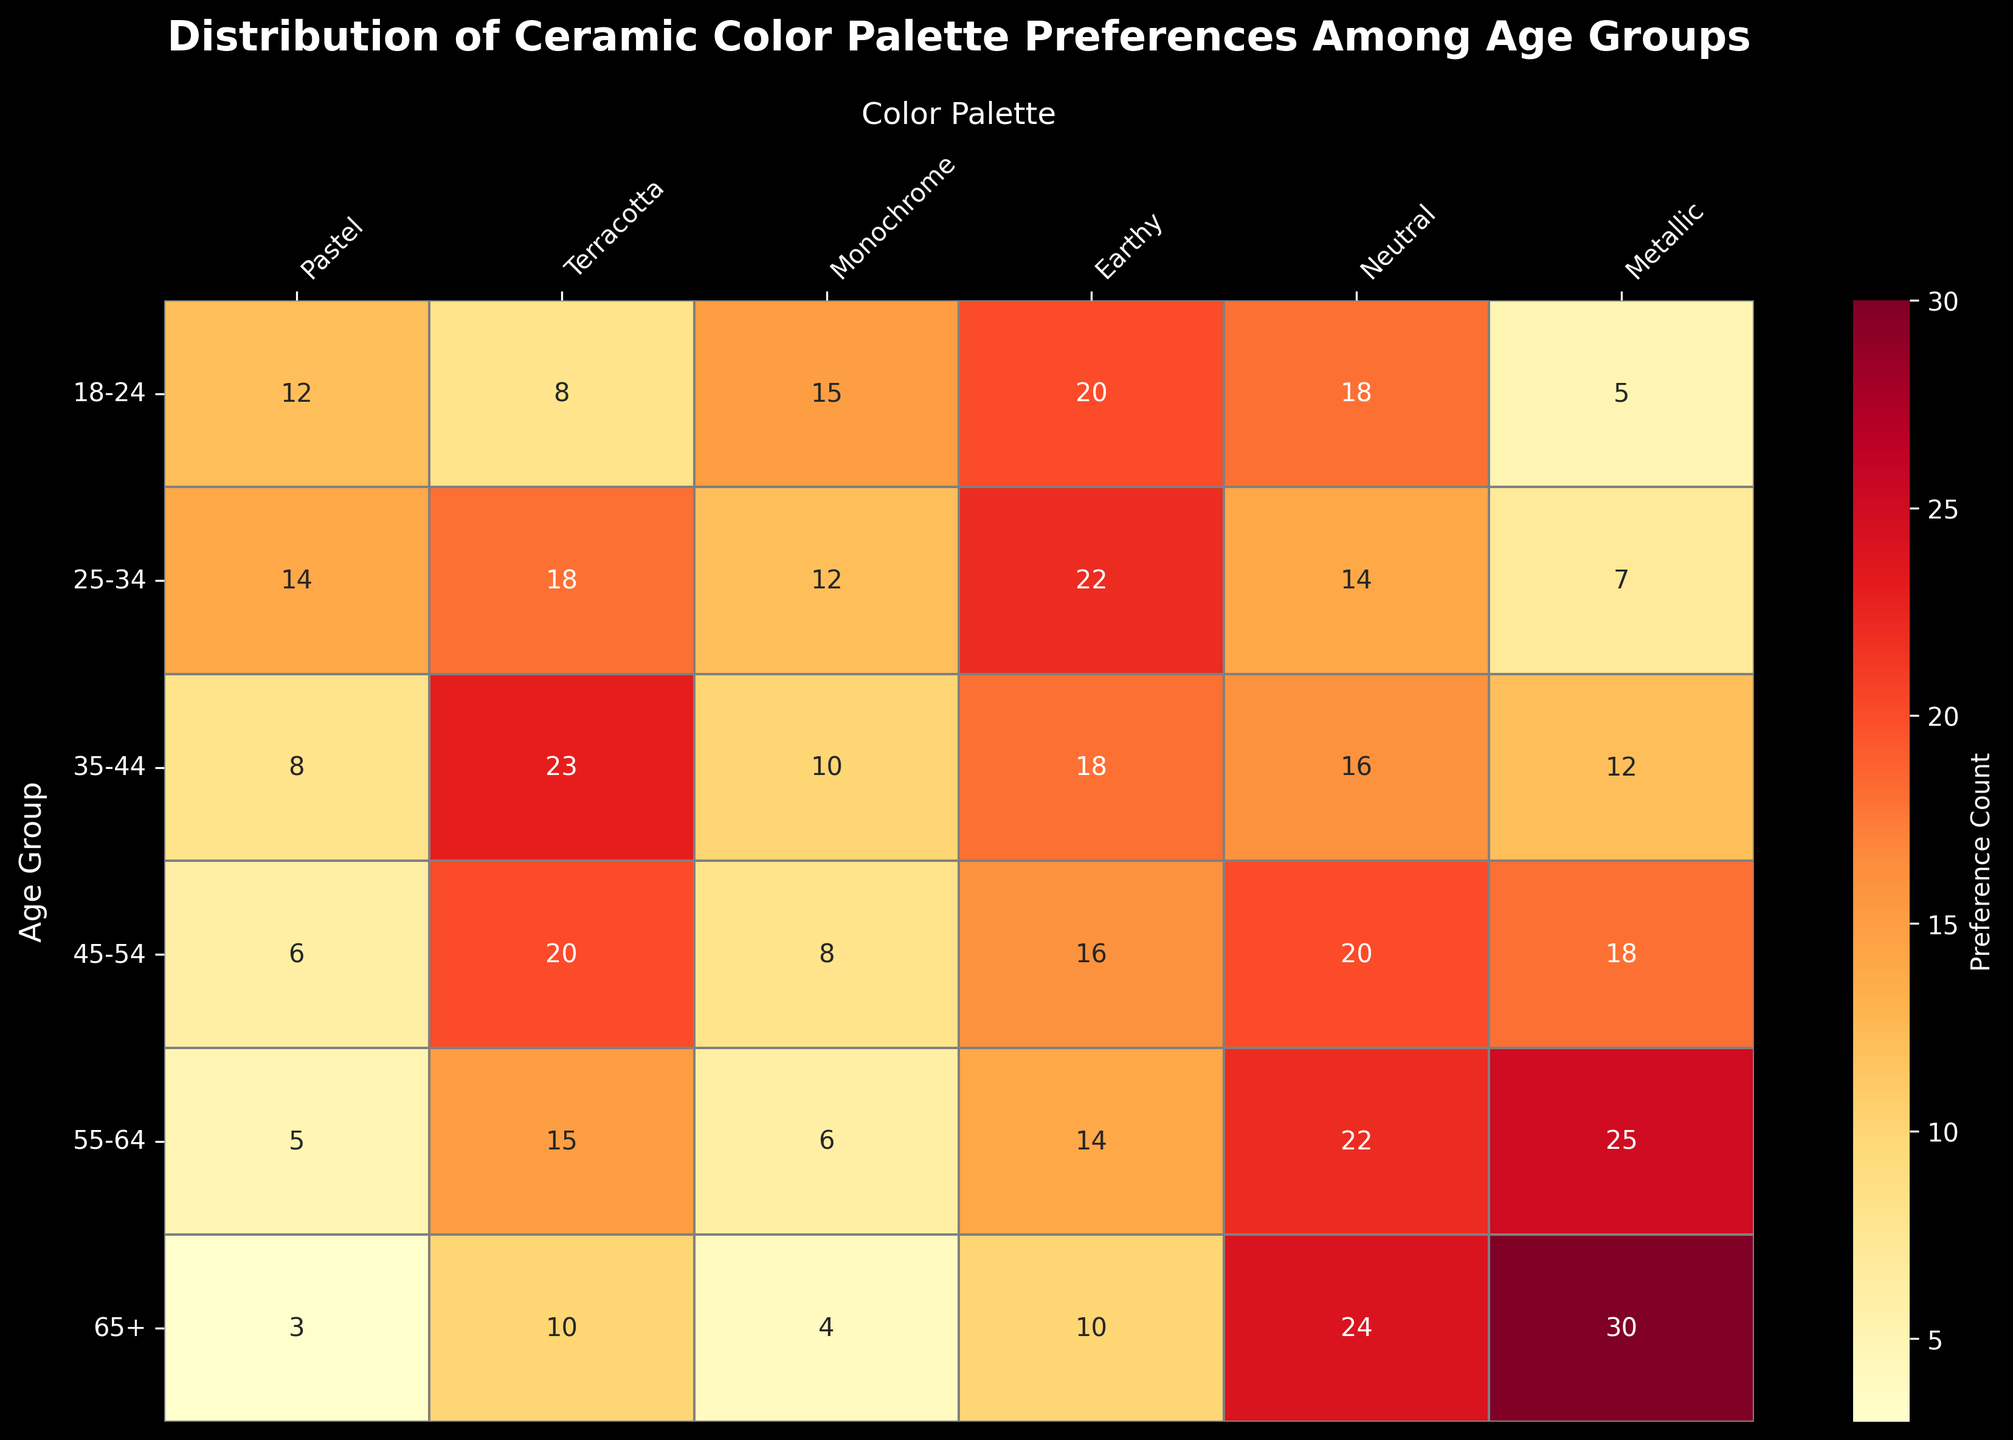What's the most popular color palette among the 25-34 age group? Look at the row corresponding to the 25-34 age group and find the highest value. The highest count is 22 under the 'Earthy' palette.
Answer: Earthy Which age group has the highest preference for Metallic colors? Find the column for Metallic colors and identify the row with the highest value. The highest count is 30 in the 65+ age group.
Answer: 65+ How many more people aged 35-44 prefer Terracotta compared to Pastels? Compare the values of the 35-44 age group for Terracotta (23) and Pastels (8). The difference is 23 - 8 = 15.
Answer: 15 What's the total preference count for Neutral colors across all age groups? Sum the values in the Neutral column: 18 + 14 + 16 + 20 + 22 + 24 = 114.
Answer: 114 Which age group has the least interest in Monochrome colors? Look at the Monochrome column and find the smallest value. The smallest count is 4 in the 65+ age group.
Answer: 65+ Is the preference for Earthy colors increasing or decreasing with age? Check the Earthy column starting from the 18-24 age group down to the 65+ age group: values are 20, 22, 18, 16, 14, and 10, showing a decreasing trend.
Answer: Decreasing What is the average preference count for Terracotta among all age groups? Sum the Terracotta values: 8 + 18 + 23 + 20 + 15 + 10 = 94. Divide by the number of age groups (6). The average is 94 / 6 ≈ 15.67.
Answer: 15.67 Which age group shows an equal preference for Neutral and Metallic colors? Compare the values in the Neutral and Metallic columns. The 65+ age group has the same count for both Neutral (24) and Metallic (30).
Answer: 65+ How does the preference for Pastel colors compare between the youngest (18-24) and oldest (65+) age groups? Compare the Pastel values for the 18-24 age group (12) and the 65+ age group (3). The 18-24 age group shows a higher preference.
Answer: 18-24 Are there any age groups that have a higher preference for Metallics than for Earthy colors? Compare the values in the Metallic and Earthy columns for each age group. The 55-64 and 65+ age groups have higher metallic preferences (25 and 30) compared to earthy preferences (14 and 10).
Answer: Yes 